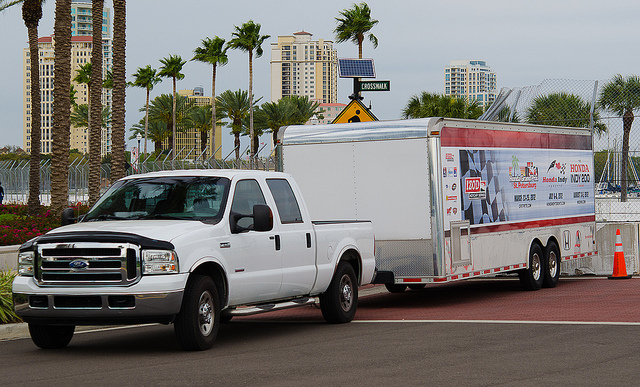<image>What kind of car is on the truck? I don't know what kind of car is on the truck. It can be a trailer, ford, pickup or a moving truck. What kind of car is on the truck? I don't know what kind of car is on the truck. It can be a trailer, a ford, a pickup, or a moving truck. 